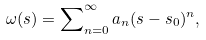Convert formula to latex. <formula><loc_0><loc_0><loc_500><loc_500>\omega ( s ) = \sum \nolimits _ { n = 0 } ^ { \infty } a _ { n } ( s - s _ { 0 } ) ^ { n } ,</formula> 